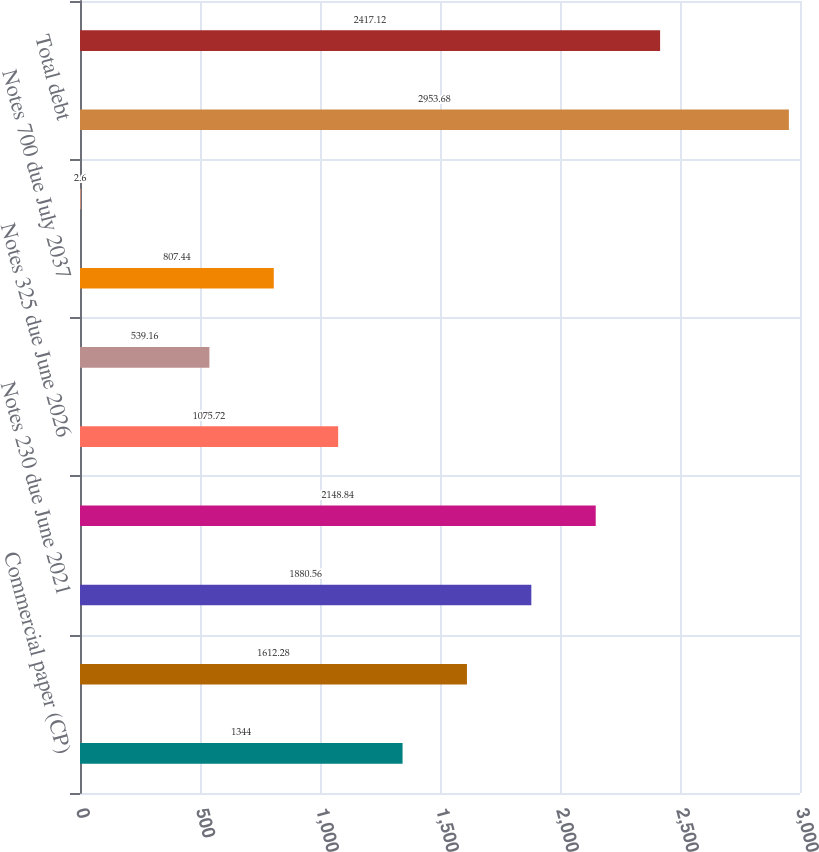<chart> <loc_0><loc_0><loc_500><loc_500><bar_chart><fcel>Commercial paper (CP)<fcel>Term loan due Nov 2018<fcel>Notes 230 due June 2021<fcel>Notes 330 due Dec 2022<fcel>Notes 325 due June 2026<fcel>Debentures 690 due July 2028<fcel>Notes 700 due July 2037<fcel>Other<fcel>Total debt<fcel>Less short-term debt and<nl><fcel>1344<fcel>1612.28<fcel>1880.56<fcel>2148.84<fcel>1075.72<fcel>539.16<fcel>807.44<fcel>2.6<fcel>2953.68<fcel>2417.12<nl></chart> 